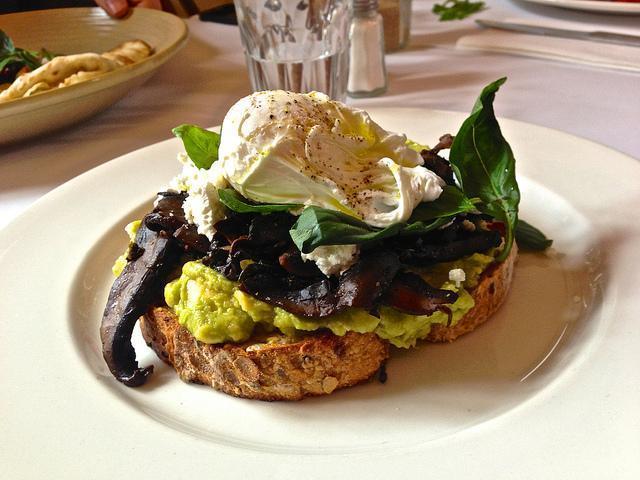Verify the accuracy of this image caption: "The bowl is in front of the sandwich.".
Answer yes or no. No. 